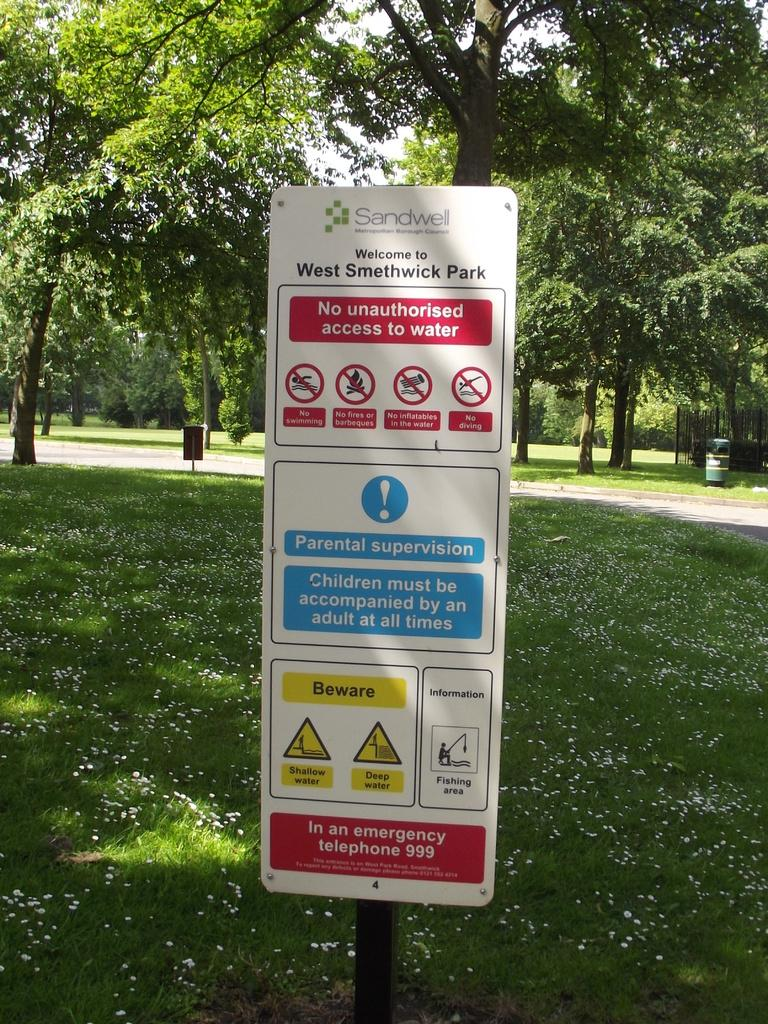What is attached to the pole in the image? There is a board attached to a pole in the image. What is on the board? The board contains a poster. What can be found on the poster? The poster has signs and text. What can be seen in the background of the image? There are trees visible in the background of the image. What type of juice is being served to the person in the image? There is no person or juice present in the image. What kind of pleasure can be derived from the poster in the image? The poster in the image is not designed to provide pleasure; it contains signs and text. 